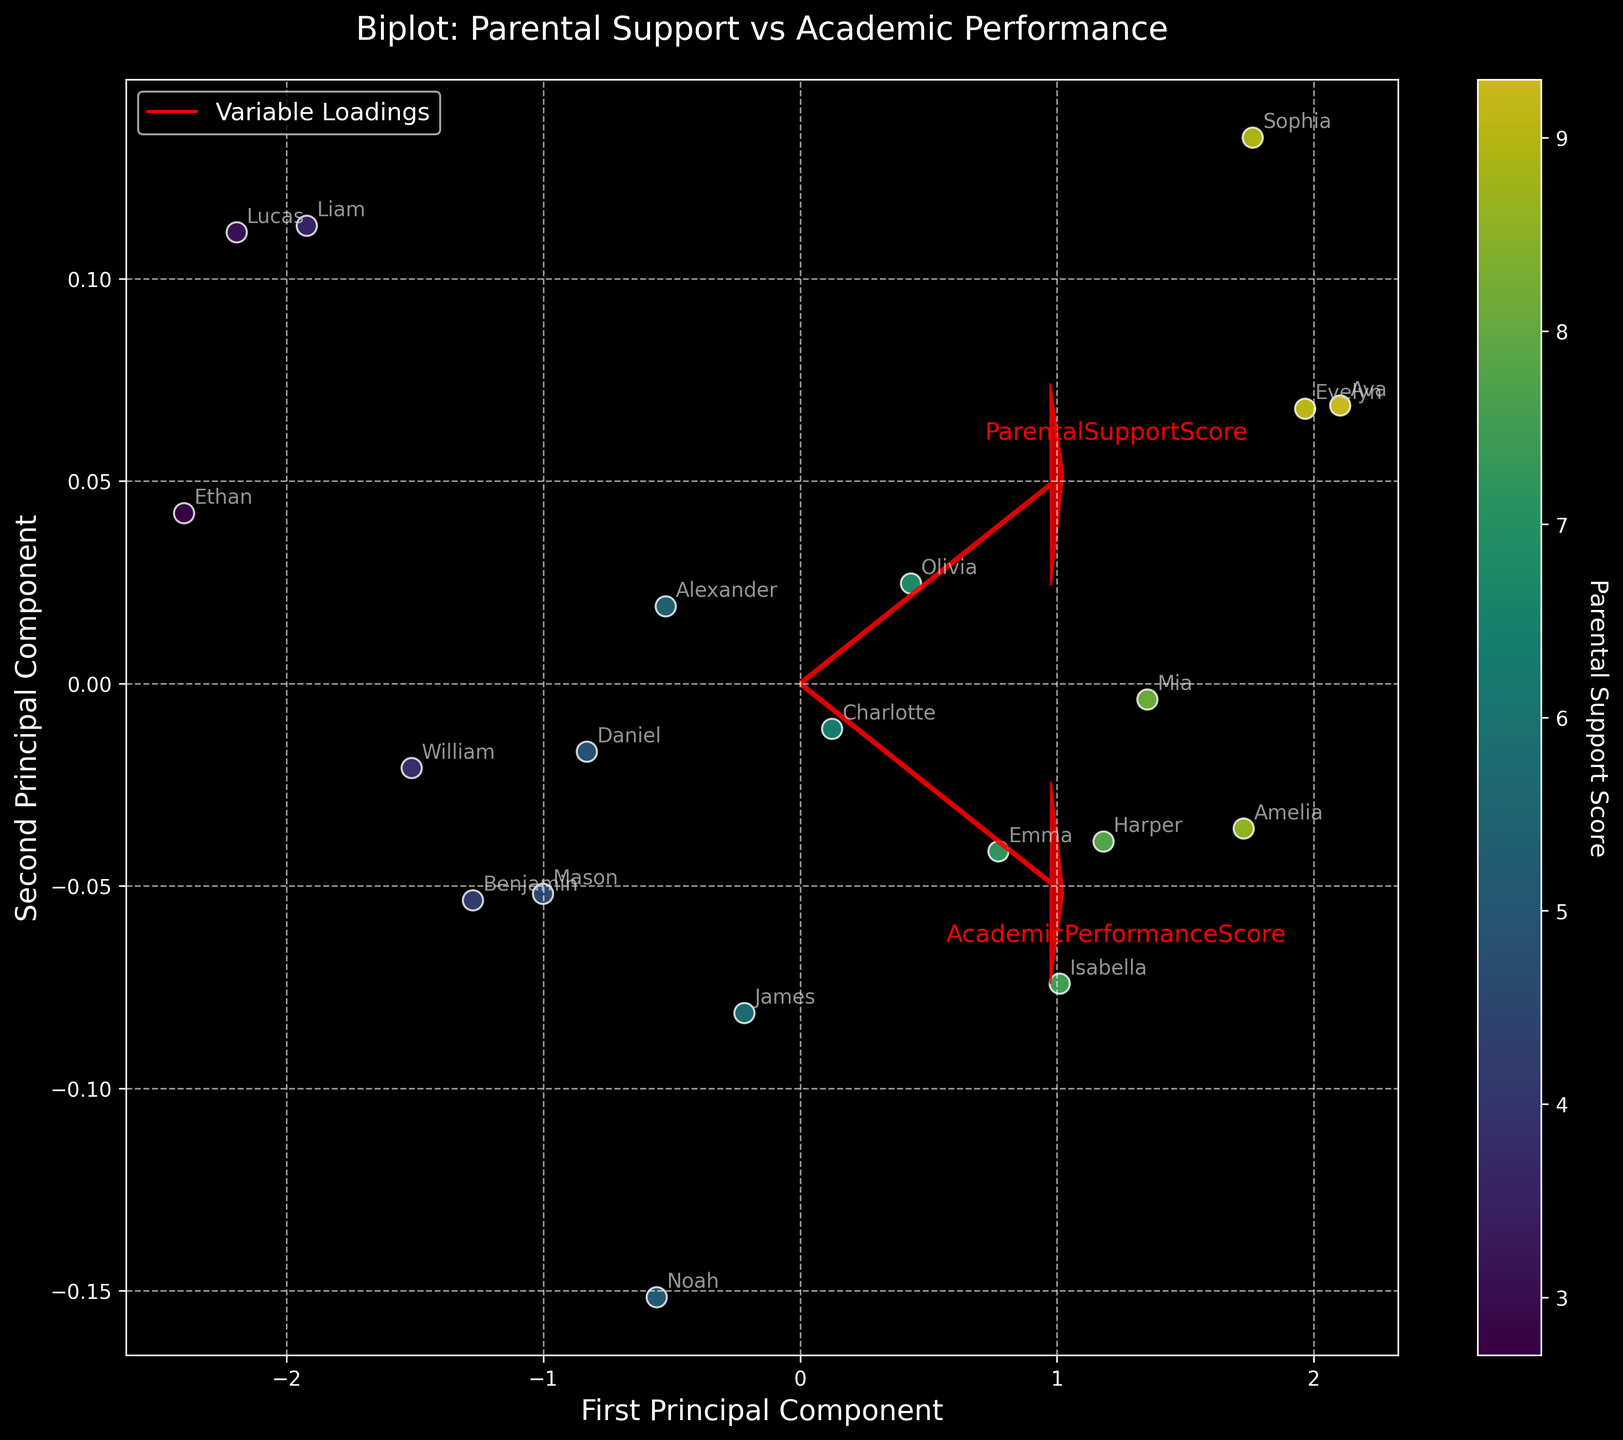What is the title of the biplot? The title of the biplot is usually displayed at the top of the figure, indicating the main topic or focus of the plot. In this case, the title is 'Biplot: Parental Support vs Academic Performance'.
Answer: Biplot: Parental Support vs Academic Performance How many data points are plotted in the biplot? Count the number of individual points or data labels in the biplot. Each data point represents a child's score in both parental support and academic performance.
Answer: 20 What color scheme is used to indicate the parental support score in the plot? The colors are used to represent different levels of parental support scores, with the color scale being shown in the colorbar on the right side. The 'viridis' colormap is used, transitioning from dark blue to yellow as values increase.
Answer: From dark blue to yellow Which principal component seems to capture more variance of the data? Look at the arrows or vectors representing the explanatory power of each principal component. The principal component that has longer arrows and accounts for more variance often points in the directions with larger data spread. Typically, the first principal component does so.
Answer: First Principal Component Are there any children with particularly high or low scores in both parental support and academic performance? Check the plot points located at the far extremes of the axes. High scores in both metrics will be positioned in the upper right, while low scores will be in the lower left. Ava and Ethan, based on the dataset, might be examples.
Answer: Yes, Ava has high scores, and Ethan has low scores How does the academic performance of children with high parental support compare to those with low parental support? Observe the general trend of data points' spreading along the colormap gradient. Children with high parental support (yellow points) generally appear further along the axis representing academic performance.
Answer: Higher parental support generally corresponds to better academic performance Which variables are represented by the arrows in the biplot? The arrows in a biplot typically represent the variables' loadings, showing how the original variables relate to the principal components. There should be two arrows here, one for each of 'Parental Support Score' and 'Academic Performance Score'.
Answer: Parental Support Score and Academic Performance Score Where is the academic performance score of the child 'Noah' located in the biplot? To locate Noah's academic performance score, find his labeled point and check its position along the axis corresponding to academic performance. Noah's values in the dataset place him at a moderate level.
Answer: Moderate level (73) What does it mean if a point is located near the tip of a variable's arrow? Points near the tip of an arrow show a higher correlation with that variable, meaning those children have higher scores on that variable.
Answer: Higher correlation with that variable Which direction do the arrows of 'Parental Support Score' and 'Academic Performance Score' point to, and what can you infer from their orientation? The direction of the arrows indicates how the variables load onto the principal components. If the arrows point in similar directions, the variables are positively correlated. The 'Parental Support Score' and 'Academic Performance Score' likely point similarly, suggesting a positive correlation.
Answer: Positive correlation 